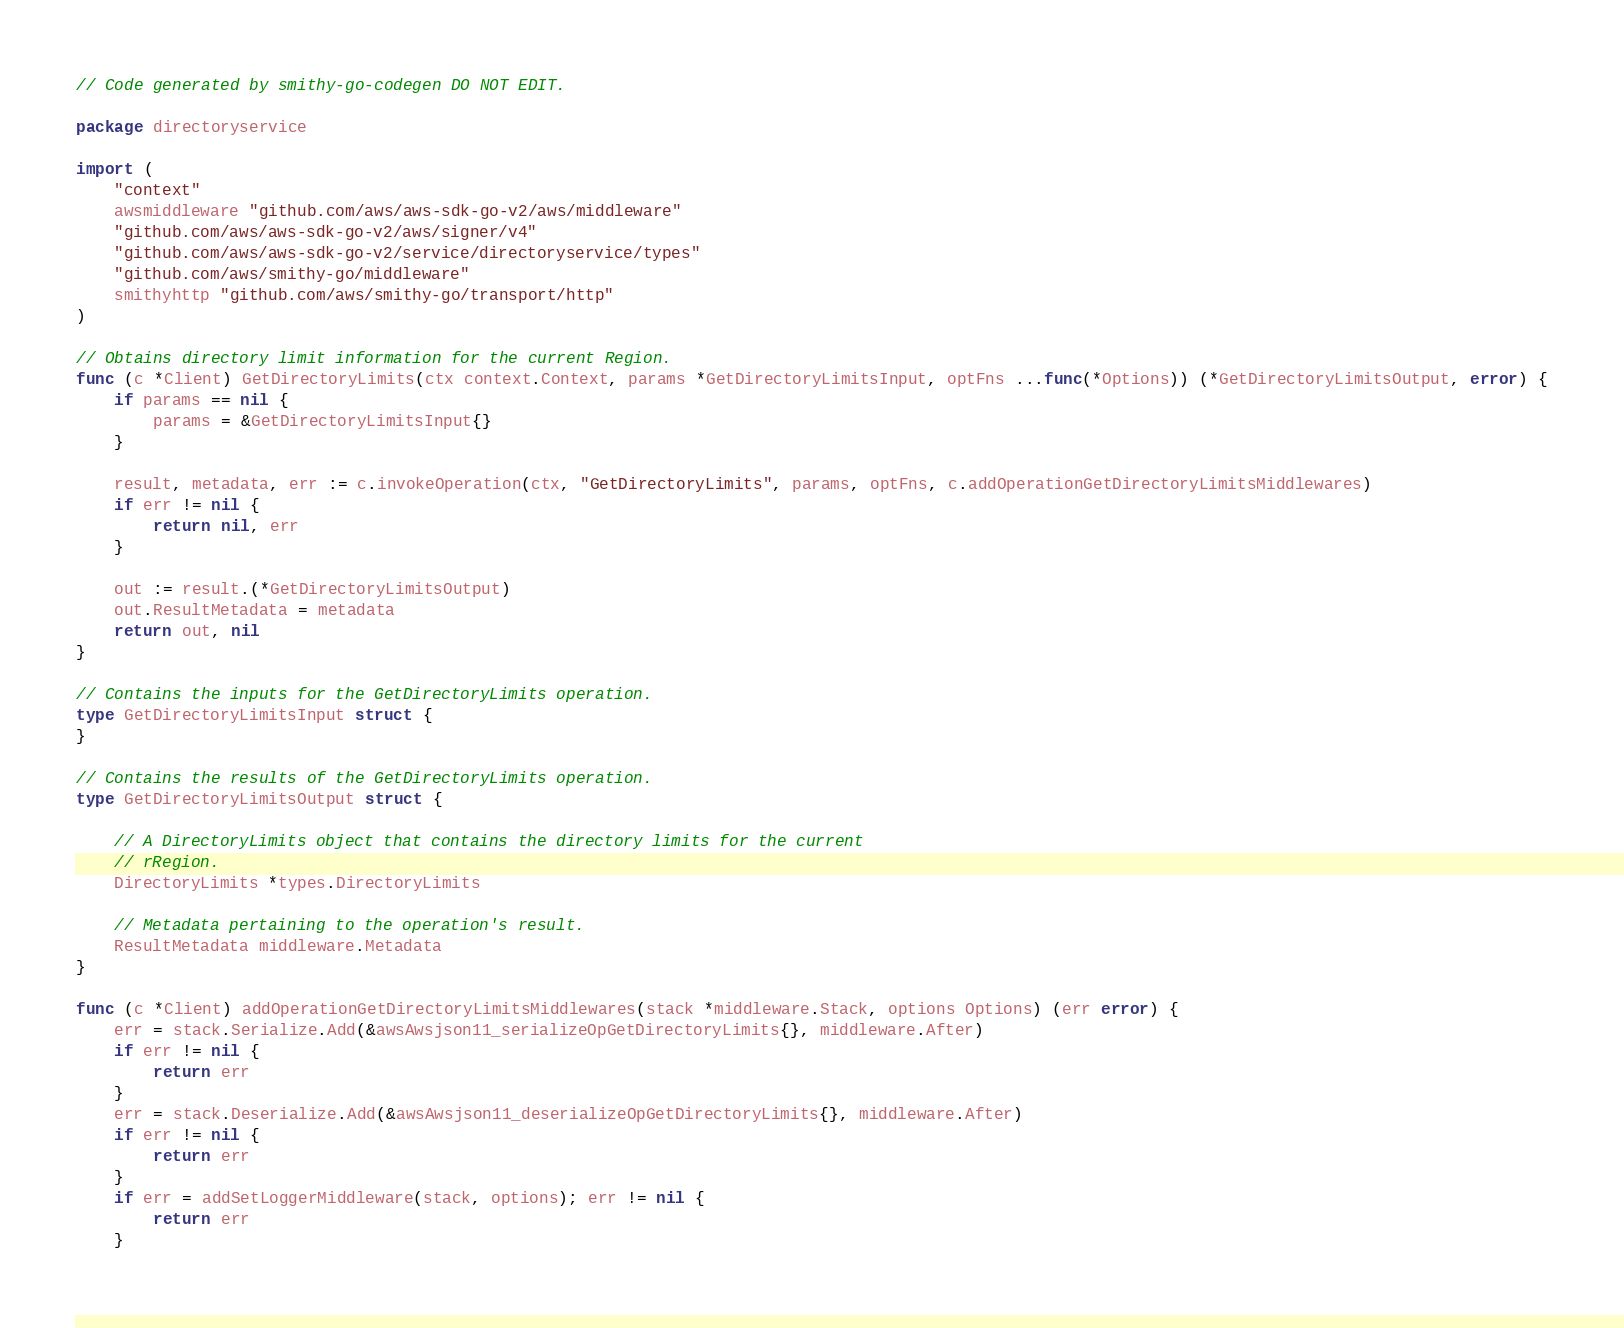Convert code to text. <code><loc_0><loc_0><loc_500><loc_500><_Go_>// Code generated by smithy-go-codegen DO NOT EDIT.

package directoryservice

import (
	"context"
	awsmiddleware "github.com/aws/aws-sdk-go-v2/aws/middleware"
	"github.com/aws/aws-sdk-go-v2/aws/signer/v4"
	"github.com/aws/aws-sdk-go-v2/service/directoryservice/types"
	"github.com/aws/smithy-go/middleware"
	smithyhttp "github.com/aws/smithy-go/transport/http"
)

// Obtains directory limit information for the current Region.
func (c *Client) GetDirectoryLimits(ctx context.Context, params *GetDirectoryLimitsInput, optFns ...func(*Options)) (*GetDirectoryLimitsOutput, error) {
	if params == nil {
		params = &GetDirectoryLimitsInput{}
	}

	result, metadata, err := c.invokeOperation(ctx, "GetDirectoryLimits", params, optFns, c.addOperationGetDirectoryLimitsMiddlewares)
	if err != nil {
		return nil, err
	}

	out := result.(*GetDirectoryLimitsOutput)
	out.ResultMetadata = metadata
	return out, nil
}

// Contains the inputs for the GetDirectoryLimits operation.
type GetDirectoryLimitsInput struct {
}

// Contains the results of the GetDirectoryLimits operation.
type GetDirectoryLimitsOutput struct {

	// A DirectoryLimits object that contains the directory limits for the current
	// rRegion.
	DirectoryLimits *types.DirectoryLimits

	// Metadata pertaining to the operation's result.
	ResultMetadata middleware.Metadata
}

func (c *Client) addOperationGetDirectoryLimitsMiddlewares(stack *middleware.Stack, options Options) (err error) {
	err = stack.Serialize.Add(&awsAwsjson11_serializeOpGetDirectoryLimits{}, middleware.After)
	if err != nil {
		return err
	}
	err = stack.Deserialize.Add(&awsAwsjson11_deserializeOpGetDirectoryLimits{}, middleware.After)
	if err != nil {
		return err
	}
	if err = addSetLoggerMiddleware(stack, options); err != nil {
		return err
	}</code> 